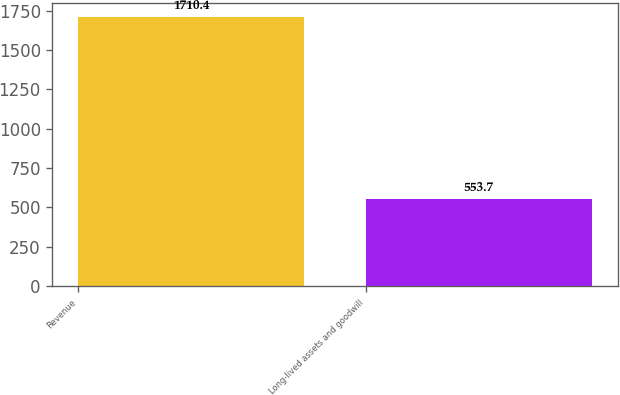Convert chart. <chart><loc_0><loc_0><loc_500><loc_500><bar_chart><fcel>Revenue<fcel>Long-lived assets and goodwill<nl><fcel>1710.4<fcel>553.7<nl></chart> 